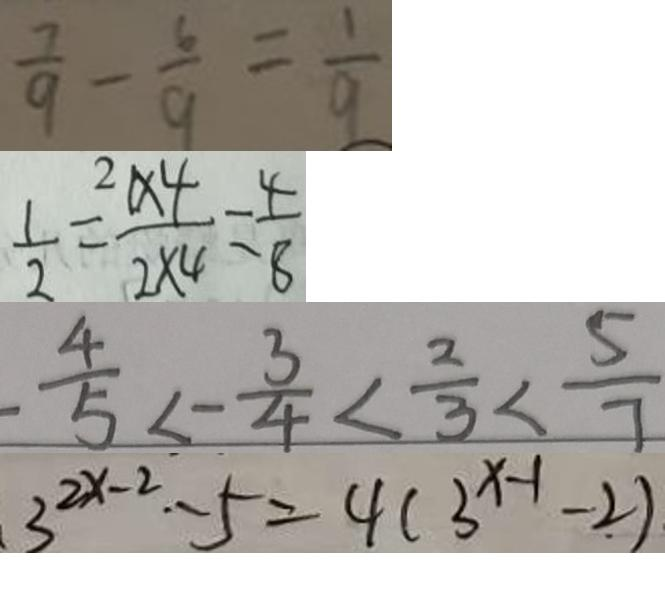Convert formula to latex. <formula><loc_0><loc_0><loc_500><loc_500>\frac { 7 } { 9 } - \frac { 6 } { 9 } = \frac { 1 } { 9 } 
 \frac { 1 } { 2 } = \frac { 1 \times 4 } { 2 \times 4 } = \frac { 4 } { 8 } 
 \frac { 4 } { 5 } < - \frac { 3 } { 4 } < \frac { 2 } { 3 } < \frac { 5 } { 7 } 
 3 ^ { 2 x - 2 } - 5 = 4 ( 3 ^ { x - 1 } - 2 )</formula> 